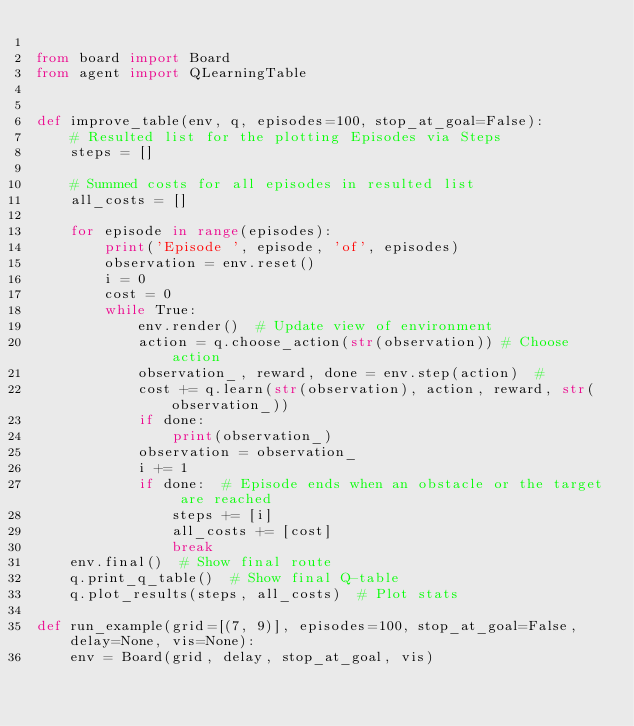Convert code to text. <code><loc_0><loc_0><loc_500><loc_500><_Python_>
from board import Board
from agent import QLearningTable


def improve_table(env, q, episodes=100, stop_at_goal=False):
    # Resulted list for the plotting Episodes via Steps
    steps = []

    # Summed costs for all episodes in resulted list
    all_costs = []

    for episode in range(episodes):
        print('Episode ', episode, 'of', episodes)
        observation = env.reset()
        i = 0
        cost = 0
        while True:
            env.render()  # Update view of environment
            action = q.choose_action(str(observation)) # Choose action
            observation_, reward, done = env.step(action)  # 
            cost += q.learn(str(observation), action, reward, str(observation_))
            if done:
                print(observation_)
            observation = observation_
            i += 1
            if done:  # Episode ends when an obstacle or the target are reached
                steps += [i]
                all_costs += [cost]
                break
    env.final()  # Show final route
    q.print_q_table()  # Show final Q-table
    q.plot_results(steps, all_costs)  # Plot stats

def run_example(grid=[(7, 9)], episodes=100, stop_at_goal=False, delay=None, vis=None):
    env = Board(grid, delay, stop_at_goal, vis)</code> 